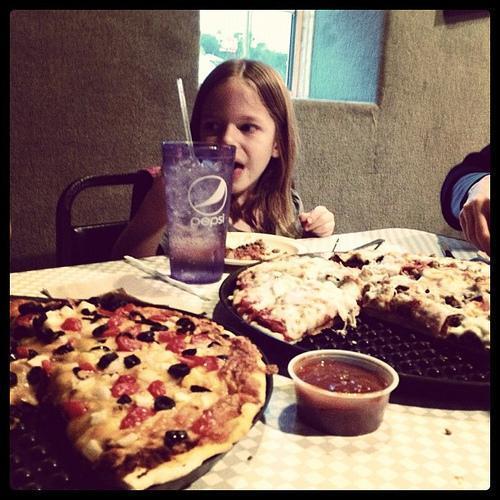How many cups of tomato sauce is there?
Give a very brief answer. 1. 